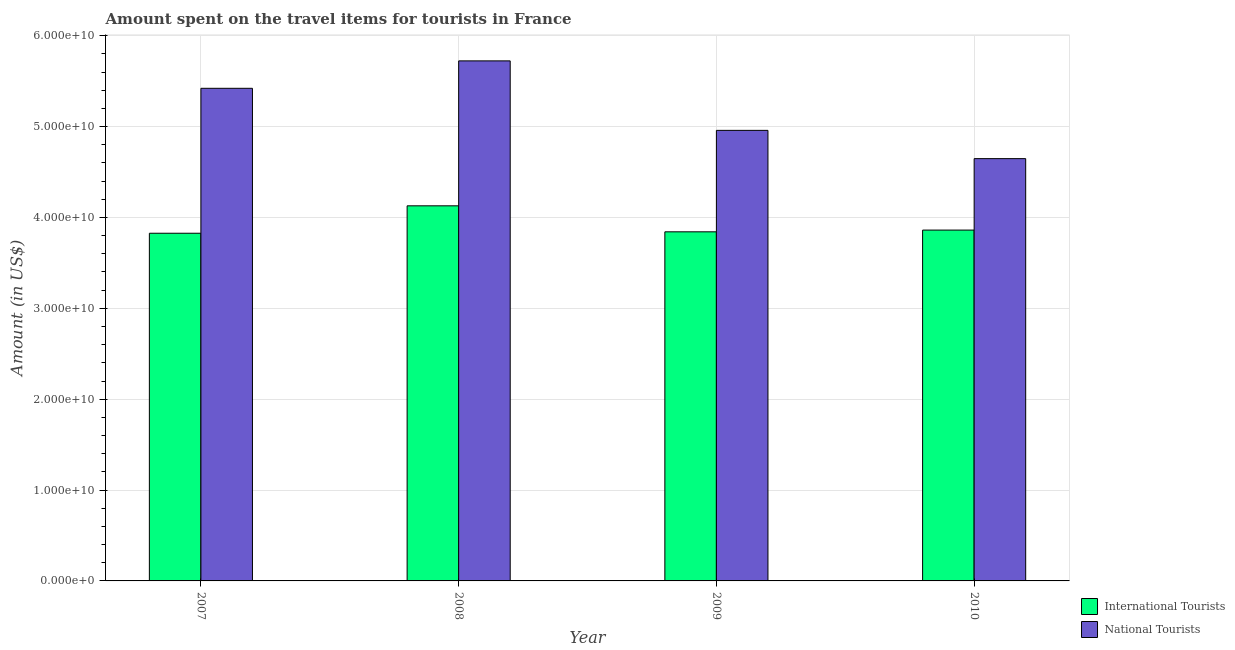How many different coloured bars are there?
Make the answer very short. 2. How many bars are there on the 1st tick from the left?
Give a very brief answer. 2. How many bars are there on the 2nd tick from the right?
Your answer should be compact. 2. What is the label of the 1st group of bars from the left?
Your answer should be very brief. 2007. In how many cases, is the number of bars for a given year not equal to the number of legend labels?
Offer a terse response. 0. What is the amount spent on travel items of international tourists in 2008?
Your answer should be compact. 4.13e+1. Across all years, what is the maximum amount spent on travel items of international tourists?
Offer a terse response. 4.13e+1. Across all years, what is the minimum amount spent on travel items of national tourists?
Your response must be concise. 4.65e+1. In which year was the amount spent on travel items of national tourists maximum?
Keep it short and to the point. 2008. What is the total amount spent on travel items of international tourists in the graph?
Provide a short and direct response. 1.57e+11. What is the difference between the amount spent on travel items of international tourists in 2007 and that in 2008?
Keep it short and to the point. -3.02e+09. What is the difference between the amount spent on travel items of international tourists in 2008 and the amount spent on travel items of national tourists in 2007?
Keep it short and to the point. 3.02e+09. What is the average amount spent on travel items of national tourists per year?
Make the answer very short. 5.19e+1. In how many years, is the amount spent on travel items of international tourists greater than 36000000000 US$?
Your answer should be very brief. 4. What is the ratio of the amount spent on travel items of national tourists in 2007 to that in 2009?
Offer a very short reply. 1.09. Is the amount spent on travel items of international tourists in 2007 less than that in 2010?
Offer a terse response. Yes. What is the difference between the highest and the second highest amount spent on travel items of international tourists?
Provide a succinct answer. 2.67e+09. What is the difference between the highest and the lowest amount spent on travel items of national tourists?
Your answer should be very brief. 1.08e+1. What does the 1st bar from the left in 2007 represents?
Provide a succinct answer. International Tourists. What does the 2nd bar from the right in 2009 represents?
Your response must be concise. International Tourists. How many bars are there?
Make the answer very short. 8. Are all the bars in the graph horizontal?
Offer a very short reply. No. How many years are there in the graph?
Your response must be concise. 4. Are the values on the major ticks of Y-axis written in scientific E-notation?
Make the answer very short. Yes. Does the graph contain any zero values?
Provide a succinct answer. No. What is the title of the graph?
Make the answer very short. Amount spent on the travel items for tourists in France. Does "Start a business" appear as one of the legend labels in the graph?
Your response must be concise. No. What is the Amount (in US$) in International Tourists in 2007?
Make the answer very short. 3.83e+1. What is the Amount (in US$) of National Tourists in 2007?
Your answer should be very brief. 5.42e+1. What is the Amount (in US$) of International Tourists in 2008?
Your response must be concise. 4.13e+1. What is the Amount (in US$) of National Tourists in 2008?
Provide a succinct answer. 5.72e+1. What is the Amount (in US$) in International Tourists in 2009?
Your answer should be compact. 3.84e+1. What is the Amount (in US$) in National Tourists in 2009?
Keep it short and to the point. 4.96e+1. What is the Amount (in US$) of International Tourists in 2010?
Your answer should be very brief. 3.86e+1. What is the Amount (in US$) of National Tourists in 2010?
Ensure brevity in your answer.  4.65e+1. Across all years, what is the maximum Amount (in US$) of International Tourists?
Provide a short and direct response. 4.13e+1. Across all years, what is the maximum Amount (in US$) of National Tourists?
Ensure brevity in your answer.  5.72e+1. Across all years, what is the minimum Amount (in US$) in International Tourists?
Give a very brief answer. 3.83e+1. Across all years, what is the minimum Amount (in US$) in National Tourists?
Give a very brief answer. 4.65e+1. What is the total Amount (in US$) in International Tourists in the graph?
Provide a short and direct response. 1.57e+11. What is the total Amount (in US$) of National Tourists in the graph?
Keep it short and to the point. 2.07e+11. What is the difference between the Amount (in US$) of International Tourists in 2007 and that in 2008?
Offer a terse response. -3.02e+09. What is the difference between the Amount (in US$) in National Tourists in 2007 and that in 2008?
Your answer should be very brief. -3.02e+09. What is the difference between the Amount (in US$) in International Tourists in 2007 and that in 2009?
Provide a succinct answer. -1.55e+08. What is the difference between the Amount (in US$) of National Tourists in 2007 and that in 2009?
Your answer should be compact. 4.63e+09. What is the difference between the Amount (in US$) of International Tourists in 2007 and that in 2010?
Your answer should be compact. -3.47e+08. What is the difference between the Amount (in US$) in National Tourists in 2007 and that in 2010?
Your answer should be very brief. 7.74e+09. What is the difference between the Amount (in US$) in International Tourists in 2008 and that in 2009?
Give a very brief answer. 2.86e+09. What is the difference between the Amount (in US$) in National Tourists in 2008 and that in 2009?
Your answer should be very brief. 7.65e+09. What is the difference between the Amount (in US$) in International Tourists in 2008 and that in 2010?
Ensure brevity in your answer.  2.67e+09. What is the difference between the Amount (in US$) of National Tourists in 2008 and that in 2010?
Offer a terse response. 1.08e+1. What is the difference between the Amount (in US$) of International Tourists in 2009 and that in 2010?
Give a very brief answer. -1.92e+08. What is the difference between the Amount (in US$) of National Tourists in 2009 and that in 2010?
Provide a succinct answer. 3.11e+09. What is the difference between the Amount (in US$) in International Tourists in 2007 and the Amount (in US$) in National Tourists in 2008?
Give a very brief answer. -1.90e+1. What is the difference between the Amount (in US$) of International Tourists in 2007 and the Amount (in US$) of National Tourists in 2009?
Keep it short and to the point. -1.13e+1. What is the difference between the Amount (in US$) of International Tourists in 2007 and the Amount (in US$) of National Tourists in 2010?
Give a very brief answer. -8.21e+09. What is the difference between the Amount (in US$) of International Tourists in 2008 and the Amount (in US$) of National Tourists in 2009?
Offer a terse response. -8.30e+09. What is the difference between the Amount (in US$) in International Tourists in 2008 and the Amount (in US$) in National Tourists in 2010?
Your response must be concise. -5.19e+09. What is the difference between the Amount (in US$) in International Tourists in 2009 and the Amount (in US$) in National Tourists in 2010?
Your answer should be very brief. -8.06e+09. What is the average Amount (in US$) of International Tourists per year?
Ensure brevity in your answer.  3.91e+1. What is the average Amount (in US$) of National Tourists per year?
Offer a very short reply. 5.19e+1. In the year 2007, what is the difference between the Amount (in US$) of International Tourists and Amount (in US$) of National Tourists?
Keep it short and to the point. -1.59e+1. In the year 2008, what is the difference between the Amount (in US$) of International Tourists and Amount (in US$) of National Tourists?
Provide a succinct answer. -1.60e+1. In the year 2009, what is the difference between the Amount (in US$) in International Tourists and Amount (in US$) in National Tourists?
Your answer should be very brief. -1.12e+1. In the year 2010, what is the difference between the Amount (in US$) in International Tourists and Amount (in US$) in National Tourists?
Give a very brief answer. -7.86e+09. What is the ratio of the Amount (in US$) in International Tourists in 2007 to that in 2008?
Provide a short and direct response. 0.93. What is the ratio of the Amount (in US$) of National Tourists in 2007 to that in 2008?
Give a very brief answer. 0.95. What is the ratio of the Amount (in US$) in National Tourists in 2007 to that in 2009?
Your answer should be compact. 1.09. What is the ratio of the Amount (in US$) in International Tourists in 2007 to that in 2010?
Make the answer very short. 0.99. What is the ratio of the Amount (in US$) in National Tourists in 2007 to that in 2010?
Make the answer very short. 1.17. What is the ratio of the Amount (in US$) in International Tourists in 2008 to that in 2009?
Keep it short and to the point. 1.07. What is the ratio of the Amount (in US$) of National Tourists in 2008 to that in 2009?
Offer a very short reply. 1.15. What is the ratio of the Amount (in US$) in International Tourists in 2008 to that in 2010?
Make the answer very short. 1.07. What is the ratio of the Amount (in US$) of National Tourists in 2008 to that in 2010?
Your response must be concise. 1.23. What is the ratio of the Amount (in US$) of International Tourists in 2009 to that in 2010?
Offer a very short reply. 0.99. What is the ratio of the Amount (in US$) in National Tourists in 2009 to that in 2010?
Provide a short and direct response. 1.07. What is the difference between the highest and the second highest Amount (in US$) of International Tourists?
Provide a succinct answer. 2.67e+09. What is the difference between the highest and the second highest Amount (in US$) of National Tourists?
Offer a terse response. 3.02e+09. What is the difference between the highest and the lowest Amount (in US$) of International Tourists?
Make the answer very short. 3.02e+09. What is the difference between the highest and the lowest Amount (in US$) of National Tourists?
Your answer should be very brief. 1.08e+1. 